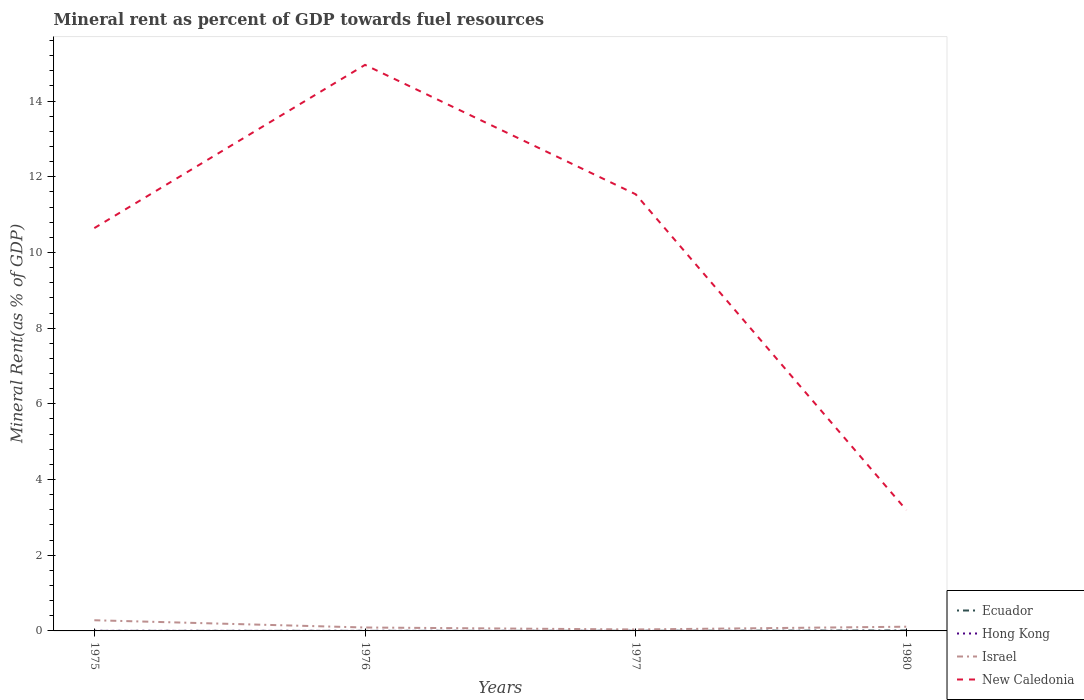Across all years, what is the maximum mineral rent in New Caledonia?
Offer a very short reply. 3.19. In which year was the mineral rent in Ecuador maximum?
Ensure brevity in your answer.  1975. What is the total mineral rent in Israel in the graph?
Your answer should be very brief. -0.02. What is the difference between the highest and the second highest mineral rent in Hong Kong?
Your response must be concise. 0. What is the difference between the highest and the lowest mineral rent in New Caledonia?
Offer a very short reply. 3. How many lines are there?
Provide a succinct answer. 4. How many years are there in the graph?
Your response must be concise. 4. What is the difference between two consecutive major ticks on the Y-axis?
Offer a very short reply. 2. Are the values on the major ticks of Y-axis written in scientific E-notation?
Your response must be concise. No. Does the graph contain any zero values?
Make the answer very short. No. Does the graph contain grids?
Your answer should be compact. No. Where does the legend appear in the graph?
Provide a short and direct response. Bottom right. How many legend labels are there?
Your response must be concise. 4. What is the title of the graph?
Keep it short and to the point. Mineral rent as percent of GDP towards fuel resources. Does "Low income" appear as one of the legend labels in the graph?
Keep it short and to the point. No. What is the label or title of the X-axis?
Your response must be concise. Years. What is the label or title of the Y-axis?
Make the answer very short. Mineral Rent(as % of GDP). What is the Mineral Rent(as % of GDP) in Ecuador in 1975?
Offer a very short reply. 0. What is the Mineral Rent(as % of GDP) in Hong Kong in 1975?
Give a very brief answer. 0. What is the Mineral Rent(as % of GDP) of Israel in 1975?
Ensure brevity in your answer.  0.28. What is the Mineral Rent(as % of GDP) of New Caledonia in 1975?
Ensure brevity in your answer.  10.64. What is the Mineral Rent(as % of GDP) in Ecuador in 1976?
Provide a short and direct response. 0. What is the Mineral Rent(as % of GDP) of Hong Kong in 1976?
Provide a short and direct response. 0. What is the Mineral Rent(as % of GDP) in Israel in 1976?
Give a very brief answer. 0.09. What is the Mineral Rent(as % of GDP) in New Caledonia in 1976?
Keep it short and to the point. 14.96. What is the Mineral Rent(as % of GDP) in Ecuador in 1977?
Your answer should be compact. 0. What is the Mineral Rent(as % of GDP) of Hong Kong in 1977?
Ensure brevity in your answer.  0. What is the Mineral Rent(as % of GDP) of Israel in 1977?
Provide a succinct answer. 0.04. What is the Mineral Rent(as % of GDP) in New Caledonia in 1977?
Provide a short and direct response. 11.54. What is the Mineral Rent(as % of GDP) of Ecuador in 1980?
Your answer should be very brief. 0.01. What is the Mineral Rent(as % of GDP) in Hong Kong in 1980?
Offer a terse response. 0. What is the Mineral Rent(as % of GDP) of Israel in 1980?
Ensure brevity in your answer.  0.11. What is the Mineral Rent(as % of GDP) in New Caledonia in 1980?
Make the answer very short. 3.19. Across all years, what is the maximum Mineral Rent(as % of GDP) of Ecuador?
Keep it short and to the point. 0.01. Across all years, what is the maximum Mineral Rent(as % of GDP) in Hong Kong?
Your response must be concise. 0. Across all years, what is the maximum Mineral Rent(as % of GDP) of Israel?
Provide a short and direct response. 0.28. Across all years, what is the maximum Mineral Rent(as % of GDP) in New Caledonia?
Your answer should be compact. 14.96. Across all years, what is the minimum Mineral Rent(as % of GDP) in Ecuador?
Your answer should be very brief. 0. Across all years, what is the minimum Mineral Rent(as % of GDP) of Hong Kong?
Offer a terse response. 0. Across all years, what is the minimum Mineral Rent(as % of GDP) of Israel?
Ensure brevity in your answer.  0.04. Across all years, what is the minimum Mineral Rent(as % of GDP) of New Caledonia?
Keep it short and to the point. 3.19. What is the total Mineral Rent(as % of GDP) in Ecuador in the graph?
Provide a short and direct response. 0.02. What is the total Mineral Rent(as % of GDP) of Hong Kong in the graph?
Provide a short and direct response. 0.01. What is the total Mineral Rent(as % of GDP) in Israel in the graph?
Make the answer very short. 0.52. What is the total Mineral Rent(as % of GDP) in New Caledonia in the graph?
Give a very brief answer. 40.33. What is the difference between the Mineral Rent(as % of GDP) in Ecuador in 1975 and that in 1976?
Offer a terse response. -0. What is the difference between the Mineral Rent(as % of GDP) in Hong Kong in 1975 and that in 1976?
Keep it short and to the point. 0. What is the difference between the Mineral Rent(as % of GDP) in Israel in 1975 and that in 1976?
Your answer should be very brief. 0.19. What is the difference between the Mineral Rent(as % of GDP) in New Caledonia in 1975 and that in 1976?
Offer a terse response. -4.31. What is the difference between the Mineral Rent(as % of GDP) of Ecuador in 1975 and that in 1977?
Provide a succinct answer. -0. What is the difference between the Mineral Rent(as % of GDP) in Hong Kong in 1975 and that in 1977?
Ensure brevity in your answer.  0. What is the difference between the Mineral Rent(as % of GDP) in Israel in 1975 and that in 1977?
Your answer should be compact. 0.24. What is the difference between the Mineral Rent(as % of GDP) of New Caledonia in 1975 and that in 1977?
Offer a terse response. -0.89. What is the difference between the Mineral Rent(as % of GDP) in Ecuador in 1975 and that in 1980?
Ensure brevity in your answer.  -0.01. What is the difference between the Mineral Rent(as % of GDP) of Hong Kong in 1975 and that in 1980?
Provide a short and direct response. 0. What is the difference between the Mineral Rent(as % of GDP) in Israel in 1975 and that in 1980?
Give a very brief answer. 0.17. What is the difference between the Mineral Rent(as % of GDP) in New Caledonia in 1975 and that in 1980?
Give a very brief answer. 7.45. What is the difference between the Mineral Rent(as % of GDP) of Ecuador in 1976 and that in 1977?
Make the answer very short. -0. What is the difference between the Mineral Rent(as % of GDP) in Hong Kong in 1976 and that in 1977?
Make the answer very short. 0. What is the difference between the Mineral Rent(as % of GDP) in Israel in 1976 and that in 1977?
Make the answer very short. 0.05. What is the difference between the Mineral Rent(as % of GDP) in New Caledonia in 1976 and that in 1977?
Offer a very short reply. 3.42. What is the difference between the Mineral Rent(as % of GDP) in Ecuador in 1976 and that in 1980?
Provide a succinct answer. -0.01. What is the difference between the Mineral Rent(as % of GDP) in Hong Kong in 1976 and that in 1980?
Give a very brief answer. 0. What is the difference between the Mineral Rent(as % of GDP) in Israel in 1976 and that in 1980?
Keep it short and to the point. -0.02. What is the difference between the Mineral Rent(as % of GDP) in New Caledonia in 1976 and that in 1980?
Provide a short and direct response. 11.77. What is the difference between the Mineral Rent(as % of GDP) of Ecuador in 1977 and that in 1980?
Your response must be concise. -0.01. What is the difference between the Mineral Rent(as % of GDP) in Israel in 1977 and that in 1980?
Offer a terse response. -0.07. What is the difference between the Mineral Rent(as % of GDP) in New Caledonia in 1977 and that in 1980?
Provide a succinct answer. 8.35. What is the difference between the Mineral Rent(as % of GDP) of Ecuador in 1975 and the Mineral Rent(as % of GDP) of Hong Kong in 1976?
Provide a succinct answer. -0. What is the difference between the Mineral Rent(as % of GDP) of Ecuador in 1975 and the Mineral Rent(as % of GDP) of Israel in 1976?
Offer a very short reply. -0.09. What is the difference between the Mineral Rent(as % of GDP) of Ecuador in 1975 and the Mineral Rent(as % of GDP) of New Caledonia in 1976?
Keep it short and to the point. -14.96. What is the difference between the Mineral Rent(as % of GDP) of Hong Kong in 1975 and the Mineral Rent(as % of GDP) of Israel in 1976?
Your answer should be very brief. -0.09. What is the difference between the Mineral Rent(as % of GDP) in Hong Kong in 1975 and the Mineral Rent(as % of GDP) in New Caledonia in 1976?
Offer a very short reply. -14.95. What is the difference between the Mineral Rent(as % of GDP) in Israel in 1975 and the Mineral Rent(as % of GDP) in New Caledonia in 1976?
Your response must be concise. -14.67. What is the difference between the Mineral Rent(as % of GDP) in Ecuador in 1975 and the Mineral Rent(as % of GDP) in Hong Kong in 1977?
Provide a succinct answer. 0. What is the difference between the Mineral Rent(as % of GDP) of Ecuador in 1975 and the Mineral Rent(as % of GDP) of Israel in 1977?
Provide a succinct answer. -0.04. What is the difference between the Mineral Rent(as % of GDP) of Ecuador in 1975 and the Mineral Rent(as % of GDP) of New Caledonia in 1977?
Provide a short and direct response. -11.54. What is the difference between the Mineral Rent(as % of GDP) of Hong Kong in 1975 and the Mineral Rent(as % of GDP) of Israel in 1977?
Ensure brevity in your answer.  -0.04. What is the difference between the Mineral Rent(as % of GDP) in Hong Kong in 1975 and the Mineral Rent(as % of GDP) in New Caledonia in 1977?
Provide a succinct answer. -11.53. What is the difference between the Mineral Rent(as % of GDP) in Israel in 1975 and the Mineral Rent(as % of GDP) in New Caledonia in 1977?
Make the answer very short. -11.26. What is the difference between the Mineral Rent(as % of GDP) of Ecuador in 1975 and the Mineral Rent(as % of GDP) of Hong Kong in 1980?
Keep it short and to the point. 0. What is the difference between the Mineral Rent(as % of GDP) of Ecuador in 1975 and the Mineral Rent(as % of GDP) of Israel in 1980?
Your answer should be compact. -0.11. What is the difference between the Mineral Rent(as % of GDP) of Ecuador in 1975 and the Mineral Rent(as % of GDP) of New Caledonia in 1980?
Make the answer very short. -3.19. What is the difference between the Mineral Rent(as % of GDP) in Hong Kong in 1975 and the Mineral Rent(as % of GDP) in Israel in 1980?
Provide a short and direct response. -0.11. What is the difference between the Mineral Rent(as % of GDP) of Hong Kong in 1975 and the Mineral Rent(as % of GDP) of New Caledonia in 1980?
Your response must be concise. -3.19. What is the difference between the Mineral Rent(as % of GDP) of Israel in 1975 and the Mineral Rent(as % of GDP) of New Caledonia in 1980?
Offer a terse response. -2.91. What is the difference between the Mineral Rent(as % of GDP) of Ecuador in 1976 and the Mineral Rent(as % of GDP) of Hong Kong in 1977?
Offer a very short reply. 0. What is the difference between the Mineral Rent(as % of GDP) in Ecuador in 1976 and the Mineral Rent(as % of GDP) in Israel in 1977?
Your response must be concise. -0.04. What is the difference between the Mineral Rent(as % of GDP) in Ecuador in 1976 and the Mineral Rent(as % of GDP) in New Caledonia in 1977?
Offer a terse response. -11.54. What is the difference between the Mineral Rent(as % of GDP) of Hong Kong in 1976 and the Mineral Rent(as % of GDP) of Israel in 1977?
Keep it short and to the point. -0.04. What is the difference between the Mineral Rent(as % of GDP) of Hong Kong in 1976 and the Mineral Rent(as % of GDP) of New Caledonia in 1977?
Your answer should be very brief. -11.54. What is the difference between the Mineral Rent(as % of GDP) of Israel in 1976 and the Mineral Rent(as % of GDP) of New Caledonia in 1977?
Your answer should be compact. -11.45. What is the difference between the Mineral Rent(as % of GDP) of Ecuador in 1976 and the Mineral Rent(as % of GDP) of Hong Kong in 1980?
Keep it short and to the point. 0. What is the difference between the Mineral Rent(as % of GDP) in Ecuador in 1976 and the Mineral Rent(as % of GDP) in Israel in 1980?
Make the answer very short. -0.11. What is the difference between the Mineral Rent(as % of GDP) of Ecuador in 1976 and the Mineral Rent(as % of GDP) of New Caledonia in 1980?
Provide a succinct answer. -3.19. What is the difference between the Mineral Rent(as % of GDP) in Hong Kong in 1976 and the Mineral Rent(as % of GDP) in Israel in 1980?
Make the answer very short. -0.11. What is the difference between the Mineral Rent(as % of GDP) of Hong Kong in 1976 and the Mineral Rent(as % of GDP) of New Caledonia in 1980?
Offer a terse response. -3.19. What is the difference between the Mineral Rent(as % of GDP) in Israel in 1976 and the Mineral Rent(as % of GDP) in New Caledonia in 1980?
Your response must be concise. -3.1. What is the difference between the Mineral Rent(as % of GDP) of Ecuador in 1977 and the Mineral Rent(as % of GDP) of Hong Kong in 1980?
Provide a short and direct response. 0. What is the difference between the Mineral Rent(as % of GDP) of Ecuador in 1977 and the Mineral Rent(as % of GDP) of Israel in 1980?
Make the answer very short. -0.11. What is the difference between the Mineral Rent(as % of GDP) in Ecuador in 1977 and the Mineral Rent(as % of GDP) in New Caledonia in 1980?
Your response must be concise. -3.19. What is the difference between the Mineral Rent(as % of GDP) of Hong Kong in 1977 and the Mineral Rent(as % of GDP) of Israel in 1980?
Provide a short and direct response. -0.11. What is the difference between the Mineral Rent(as % of GDP) in Hong Kong in 1977 and the Mineral Rent(as % of GDP) in New Caledonia in 1980?
Give a very brief answer. -3.19. What is the difference between the Mineral Rent(as % of GDP) of Israel in 1977 and the Mineral Rent(as % of GDP) of New Caledonia in 1980?
Your answer should be compact. -3.15. What is the average Mineral Rent(as % of GDP) in Ecuador per year?
Offer a very short reply. 0. What is the average Mineral Rent(as % of GDP) of Hong Kong per year?
Keep it short and to the point. 0. What is the average Mineral Rent(as % of GDP) of Israel per year?
Your answer should be compact. 0.13. What is the average Mineral Rent(as % of GDP) in New Caledonia per year?
Provide a succinct answer. 10.08. In the year 1975, what is the difference between the Mineral Rent(as % of GDP) in Ecuador and Mineral Rent(as % of GDP) in Hong Kong?
Your answer should be compact. -0. In the year 1975, what is the difference between the Mineral Rent(as % of GDP) of Ecuador and Mineral Rent(as % of GDP) of Israel?
Provide a succinct answer. -0.28. In the year 1975, what is the difference between the Mineral Rent(as % of GDP) of Ecuador and Mineral Rent(as % of GDP) of New Caledonia?
Your answer should be compact. -10.64. In the year 1975, what is the difference between the Mineral Rent(as % of GDP) of Hong Kong and Mineral Rent(as % of GDP) of Israel?
Provide a succinct answer. -0.28. In the year 1975, what is the difference between the Mineral Rent(as % of GDP) of Hong Kong and Mineral Rent(as % of GDP) of New Caledonia?
Make the answer very short. -10.64. In the year 1975, what is the difference between the Mineral Rent(as % of GDP) in Israel and Mineral Rent(as % of GDP) in New Caledonia?
Make the answer very short. -10.36. In the year 1976, what is the difference between the Mineral Rent(as % of GDP) of Ecuador and Mineral Rent(as % of GDP) of Israel?
Your answer should be very brief. -0.09. In the year 1976, what is the difference between the Mineral Rent(as % of GDP) of Ecuador and Mineral Rent(as % of GDP) of New Caledonia?
Ensure brevity in your answer.  -14.95. In the year 1976, what is the difference between the Mineral Rent(as % of GDP) of Hong Kong and Mineral Rent(as % of GDP) of Israel?
Your response must be concise. -0.09. In the year 1976, what is the difference between the Mineral Rent(as % of GDP) of Hong Kong and Mineral Rent(as % of GDP) of New Caledonia?
Keep it short and to the point. -14.96. In the year 1976, what is the difference between the Mineral Rent(as % of GDP) in Israel and Mineral Rent(as % of GDP) in New Caledonia?
Keep it short and to the point. -14.87. In the year 1977, what is the difference between the Mineral Rent(as % of GDP) in Ecuador and Mineral Rent(as % of GDP) in Hong Kong?
Offer a very short reply. 0. In the year 1977, what is the difference between the Mineral Rent(as % of GDP) of Ecuador and Mineral Rent(as % of GDP) of Israel?
Make the answer very short. -0.04. In the year 1977, what is the difference between the Mineral Rent(as % of GDP) of Ecuador and Mineral Rent(as % of GDP) of New Caledonia?
Offer a very short reply. -11.53. In the year 1977, what is the difference between the Mineral Rent(as % of GDP) of Hong Kong and Mineral Rent(as % of GDP) of Israel?
Ensure brevity in your answer.  -0.04. In the year 1977, what is the difference between the Mineral Rent(as % of GDP) in Hong Kong and Mineral Rent(as % of GDP) in New Caledonia?
Offer a terse response. -11.54. In the year 1977, what is the difference between the Mineral Rent(as % of GDP) in Israel and Mineral Rent(as % of GDP) in New Caledonia?
Ensure brevity in your answer.  -11.5. In the year 1980, what is the difference between the Mineral Rent(as % of GDP) in Ecuador and Mineral Rent(as % of GDP) in Hong Kong?
Offer a very short reply. 0.01. In the year 1980, what is the difference between the Mineral Rent(as % of GDP) in Ecuador and Mineral Rent(as % of GDP) in Israel?
Make the answer very short. -0.1. In the year 1980, what is the difference between the Mineral Rent(as % of GDP) of Ecuador and Mineral Rent(as % of GDP) of New Caledonia?
Provide a short and direct response. -3.18. In the year 1980, what is the difference between the Mineral Rent(as % of GDP) of Hong Kong and Mineral Rent(as % of GDP) of Israel?
Provide a succinct answer. -0.11. In the year 1980, what is the difference between the Mineral Rent(as % of GDP) of Hong Kong and Mineral Rent(as % of GDP) of New Caledonia?
Ensure brevity in your answer.  -3.19. In the year 1980, what is the difference between the Mineral Rent(as % of GDP) in Israel and Mineral Rent(as % of GDP) in New Caledonia?
Ensure brevity in your answer.  -3.08. What is the ratio of the Mineral Rent(as % of GDP) of Ecuador in 1975 to that in 1976?
Your answer should be compact. 0.55. What is the ratio of the Mineral Rent(as % of GDP) in Hong Kong in 1975 to that in 1976?
Keep it short and to the point. 2.26. What is the ratio of the Mineral Rent(as % of GDP) in Israel in 1975 to that in 1976?
Offer a very short reply. 3.12. What is the ratio of the Mineral Rent(as % of GDP) in New Caledonia in 1975 to that in 1976?
Provide a short and direct response. 0.71. What is the ratio of the Mineral Rent(as % of GDP) of Ecuador in 1975 to that in 1977?
Provide a succinct answer. 0.29. What is the ratio of the Mineral Rent(as % of GDP) of Hong Kong in 1975 to that in 1977?
Your response must be concise. 3.44. What is the ratio of the Mineral Rent(as % of GDP) in Israel in 1975 to that in 1977?
Keep it short and to the point. 7.33. What is the ratio of the Mineral Rent(as % of GDP) of New Caledonia in 1975 to that in 1977?
Offer a very short reply. 0.92. What is the ratio of the Mineral Rent(as % of GDP) in Ecuador in 1975 to that in 1980?
Offer a terse response. 0.08. What is the ratio of the Mineral Rent(as % of GDP) in Hong Kong in 1975 to that in 1980?
Ensure brevity in your answer.  8.2. What is the ratio of the Mineral Rent(as % of GDP) in Israel in 1975 to that in 1980?
Your answer should be very brief. 2.53. What is the ratio of the Mineral Rent(as % of GDP) in New Caledonia in 1975 to that in 1980?
Your answer should be very brief. 3.33. What is the ratio of the Mineral Rent(as % of GDP) of Ecuador in 1976 to that in 1977?
Offer a terse response. 0.53. What is the ratio of the Mineral Rent(as % of GDP) in Hong Kong in 1976 to that in 1977?
Your answer should be very brief. 1.52. What is the ratio of the Mineral Rent(as % of GDP) in Israel in 1976 to that in 1977?
Keep it short and to the point. 2.35. What is the ratio of the Mineral Rent(as % of GDP) of New Caledonia in 1976 to that in 1977?
Your response must be concise. 1.3. What is the ratio of the Mineral Rent(as % of GDP) of Ecuador in 1976 to that in 1980?
Make the answer very short. 0.15. What is the ratio of the Mineral Rent(as % of GDP) in Hong Kong in 1976 to that in 1980?
Your answer should be compact. 3.62. What is the ratio of the Mineral Rent(as % of GDP) in Israel in 1976 to that in 1980?
Give a very brief answer. 0.81. What is the ratio of the Mineral Rent(as % of GDP) in New Caledonia in 1976 to that in 1980?
Your response must be concise. 4.69. What is the ratio of the Mineral Rent(as % of GDP) in Ecuador in 1977 to that in 1980?
Give a very brief answer. 0.28. What is the ratio of the Mineral Rent(as % of GDP) in Hong Kong in 1977 to that in 1980?
Provide a succinct answer. 2.38. What is the ratio of the Mineral Rent(as % of GDP) in Israel in 1977 to that in 1980?
Ensure brevity in your answer.  0.35. What is the ratio of the Mineral Rent(as % of GDP) in New Caledonia in 1977 to that in 1980?
Provide a short and direct response. 3.62. What is the difference between the highest and the second highest Mineral Rent(as % of GDP) in Ecuador?
Keep it short and to the point. 0.01. What is the difference between the highest and the second highest Mineral Rent(as % of GDP) of Hong Kong?
Ensure brevity in your answer.  0. What is the difference between the highest and the second highest Mineral Rent(as % of GDP) in Israel?
Offer a terse response. 0.17. What is the difference between the highest and the second highest Mineral Rent(as % of GDP) in New Caledonia?
Your response must be concise. 3.42. What is the difference between the highest and the lowest Mineral Rent(as % of GDP) in Ecuador?
Ensure brevity in your answer.  0.01. What is the difference between the highest and the lowest Mineral Rent(as % of GDP) in Hong Kong?
Give a very brief answer. 0. What is the difference between the highest and the lowest Mineral Rent(as % of GDP) of Israel?
Your response must be concise. 0.24. What is the difference between the highest and the lowest Mineral Rent(as % of GDP) of New Caledonia?
Give a very brief answer. 11.77. 